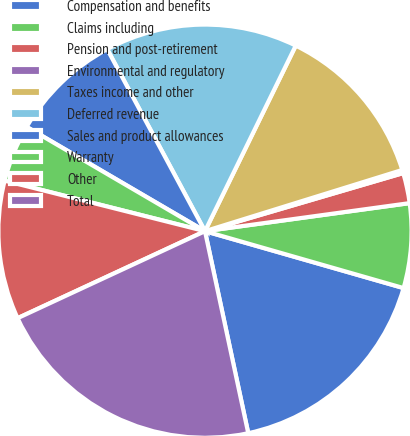Convert chart. <chart><loc_0><loc_0><loc_500><loc_500><pie_chart><fcel>Compensation and benefits<fcel>Claims including<fcel>Pension and post-retirement<fcel>Environmental and regulatory<fcel>Taxes income and other<fcel>Deferred revenue<fcel>Sales and product allowances<fcel>Warranty<fcel>Other<fcel>Total<nl><fcel>17.2%<fcel>6.61%<fcel>2.37%<fcel>0.25%<fcel>12.97%<fcel>15.09%<fcel>8.73%<fcel>4.49%<fcel>10.85%<fcel>21.44%<nl></chart> 